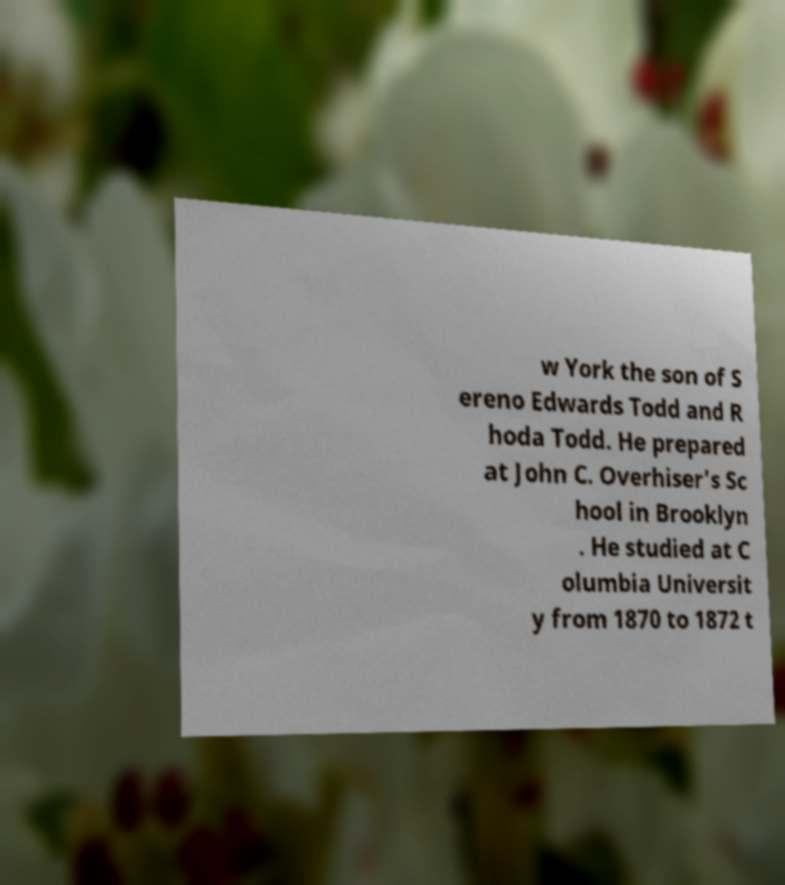Please read and relay the text visible in this image. What does it say? w York the son of S ereno Edwards Todd and R hoda Todd. He prepared at John C. Overhiser's Sc hool in Brooklyn . He studied at C olumbia Universit y from 1870 to 1872 t 